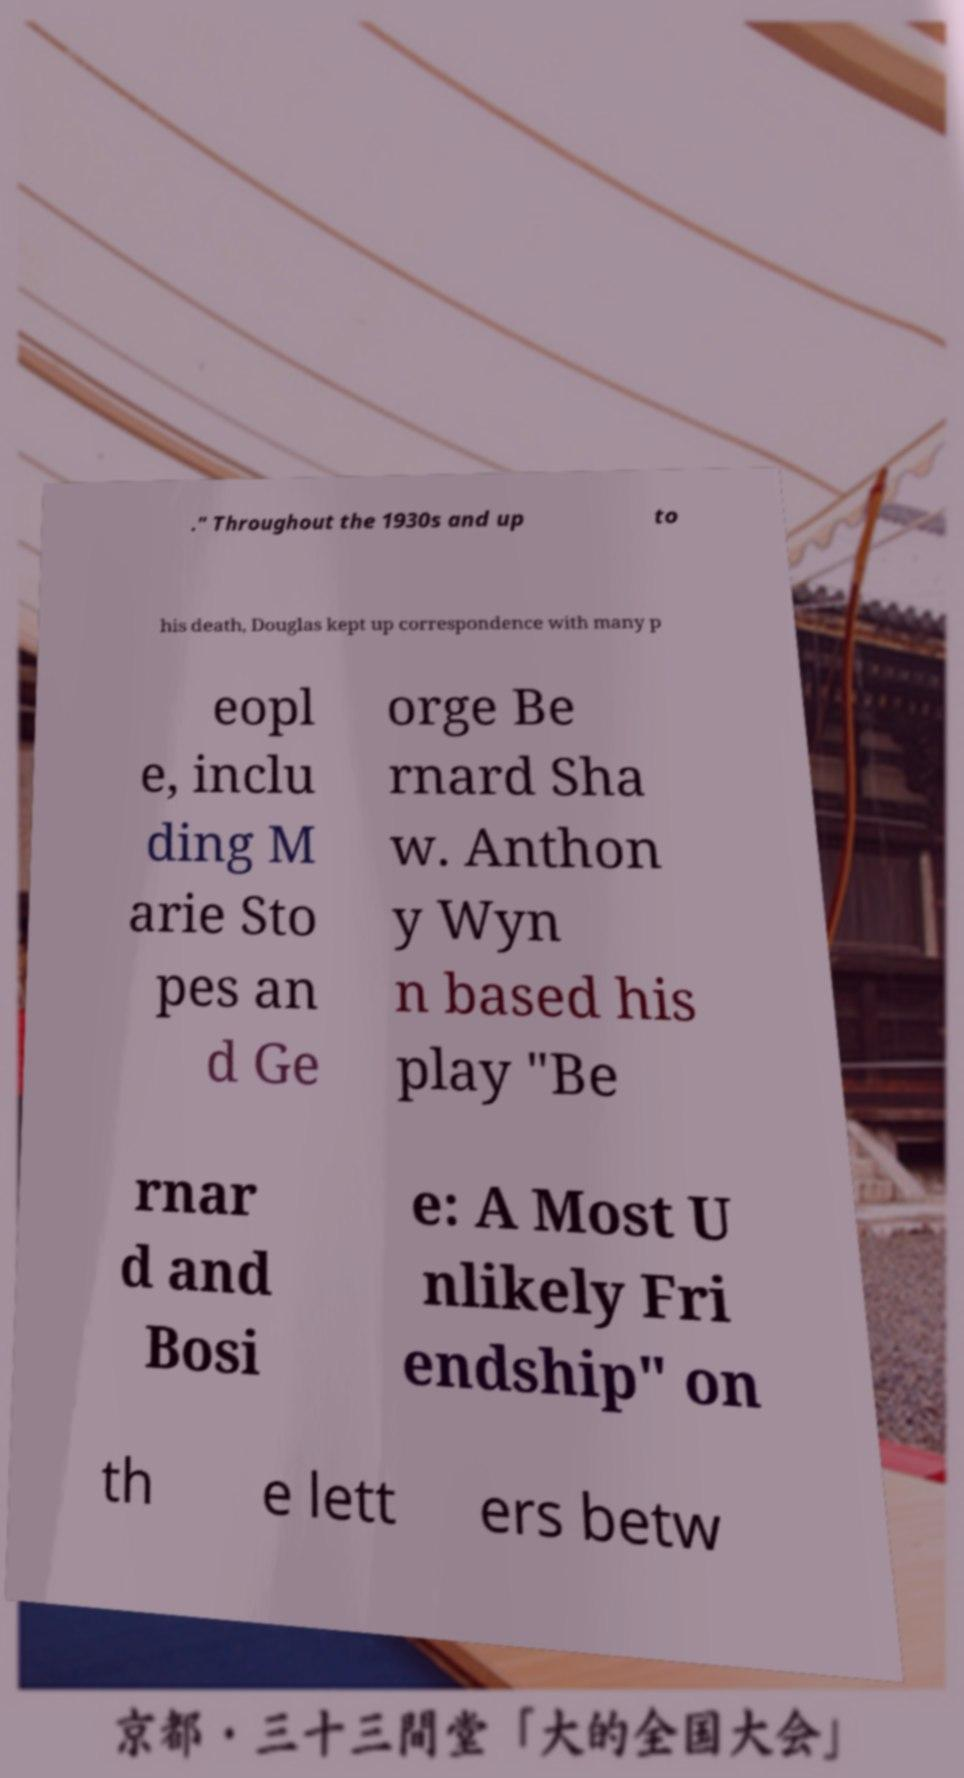Could you extract and type out the text from this image? ." Throughout the 1930s and up to his death, Douglas kept up correspondence with many p eopl e, inclu ding M arie Sto pes an d Ge orge Be rnard Sha w. Anthon y Wyn n based his play "Be rnar d and Bosi e: A Most U nlikely Fri endship" on th e lett ers betw 